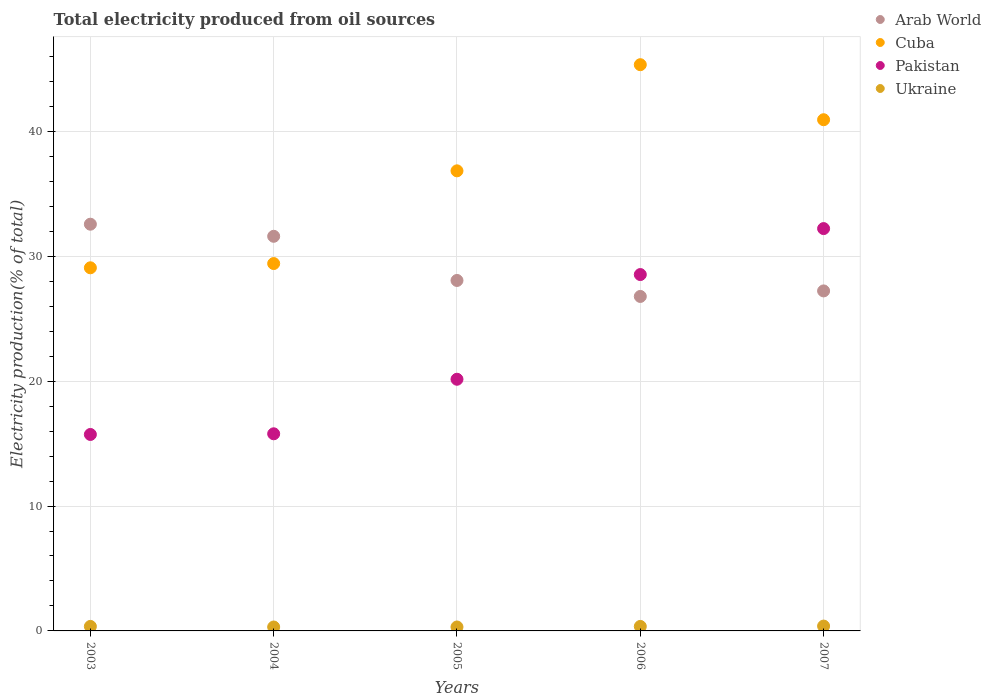What is the total electricity produced in Pakistan in 2006?
Keep it short and to the point. 28.53. Across all years, what is the maximum total electricity produced in Ukraine?
Give a very brief answer. 0.39. Across all years, what is the minimum total electricity produced in Ukraine?
Make the answer very short. 0.31. In which year was the total electricity produced in Ukraine minimum?
Offer a very short reply. 2004. What is the total total electricity produced in Cuba in the graph?
Your answer should be very brief. 181.61. What is the difference between the total electricity produced in Pakistan in 2003 and that in 2007?
Give a very brief answer. -16.49. What is the difference between the total electricity produced in Pakistan in 2004 and the total electricity produced in Cuba in 2003?
Offer a terse response. -13.29. What is the average total electricity produced in Arab World per year?
Offer a very short reply. 29.25. In the year 2007, what is the difference between the total electricity produced in Pakistan and total electricity produced in Arab World?
Offer a terse response. 4.99. What is the ratio of the total electricity produced in Cuba in 2003 to that in 2004?
Your answer should be compact. 0.99. Is the difference between the total electricity produced in Pakistan in 2004 and 2006 greater than the difference between the total electricity produced in Arab World in 2004 and 2006?
Ensure brevity in your answer.  No. What is the difference between the highest and the second highest total electricity produced in Arab World?
Ensure brevity in your answer.  0.97. What is the difference between the highest and the lowest total electricity produced in Cuba?
Make the answer very short. 16.26. Is the sum of the total electricity produced in Cuba in 2005 and 2006 greater than the maximum total electricity produced in Pakistan across all years?
Keep it short and to the point. Yes. Is it the case that in every year, the sum of the total electricity produced in Ukraine and total electricity produced in Pakistan  is greater than the sum of total electricity produced in Cuba and total electricity produced in Arab World?
Provide a short and direct response. No. Is it the case that in every year, the sum of the total electricity produced in Cuba and total electricity produced in Arab World  is greater than the total electricity produced in Pakistan?
Offer a terse response. Yes. Is the total electricity produced in Pakistan strictly greater than the total electricity produced in Ukraine over the years?
Your answer should be compact. Yes. Are the values on the major ticks of Y-axis written in scientific E-notation?
Your response must be concise. No. Does the graph contain any zero values?
Give a very brief answer. No. Does the graph contain grids?
Make the answer very short. Yes. How are the legend labels stacked?
Ensure brevity in your answer.  Vertical. What is the title of the graph?
Offer a very short reply. Total electricity produced from oil sources. What is the label or title of the Y-axis?
Offer a terse response. Electricity production(% of total). What is the Electricity production(% of total) of Arab World in 2003?
Your response must be concise. 32.57. What is the Electricity production(% of total) of Cuba in 2003?
Keep it short and to the point. 29.08. What is the Electricity production(% of total) in Pakistan in 2003?
Make the answer very short. 15.73. What is the Electricity production(% of total) of Ukraine in 2003?
Keep it short and to the point. 0.36. What is the Electricity production(% of total) in Arab World in 2004?
Give a very brief answer. 31.6. What is the Electricity production(% of total) in Cuba in 2004?
Offer a very short reply. 29.42. What is the Electricity production(% of total) of Pakistan in 2004?
Provide a succinct answer. 15.78. What is the Electricity production(% of total) in Ukraine in 2004?
Your answer should be very brief. 0.31. What is the Electricity production(% of total) in Arab World in 2005?
Your response must be concise. 28.06. What is the Electricity production(% of total) of Cuba in 2005?
Your answer should be very brief. 36.84. What is the Electricity production(% of total) of Pakistan in 2005?
Provide a short and direct response. 20.15. What is the Electricity production(% of total) in Ukraine in 2005?
Your answer should be compact. 0.32. What is the Electricity production(% of total) in Arab World in 2006?
Ensure brevity in your answer.  26.78. What is the Electricity production(% of total) in Cuba in 2006?
Your answer should be compact. 45.34. What is the Electricity production(% of total) in Pakistan in 2006?
Make the answer very short. 28.53. What is the Electricity production(% of total) in Ukraine in 2006?
Your response must be concise. 0.36. What is the Electricity production(% of total) of Arab World in 2007?
Make the answer very short. 27.23. What is the Electricity production(% of total) of Cuba in 2007?
Offer a very short reply. 40.93. What is the Electricity production(% of total) in Pakistan in 2007?
Ensure brevity in your answer.  32.22. What is the Electricity production(% of total) of Ukraine in 2007?
Ensure brevity in your answer.  0.39. Across all years, what is the maximum Electricity production(% of total) in Arab World?
Ensure brevity in your answer.  32.57. Across all years, what is the maximum Electricity production(% of total) in Cuba?
Your response must be concise. 45.34. Across all years, what is the maximum Electricity production(% of total) of Pakistan?
Ensure brevity in your answer.  32.22. Across all years, what is the maximum Electricity production(% of total) in Ukraine?
Your response must be concise. 0.39. Across all years, what is the minimum Electricity production(% of total) of Arab World?
Your response must be concise. 26.78. Across all years, what is the minimum Electricity production(% of total) of Cuba?
Your answer should be compact. 29.08. Across all years, what is the minimum Electricity production(% of total) in Pakistan?
Offer a terse response. 15.73. Across all years, what is the minimum Electricity production(% of total) in Ukraine?
Provide a succinct answer. 0.31. What is the total Electricity production(% of total) of Arab World in the graph?
Your answer should be very brief. 146.24. What is the total Electricity production(% of total) of Cuba in the graph?
Provide a short and direct response. 181.61. What is the total Electricity production(% of total) in Pakistan in the graph?
Provide a succinct answer. 112.42. What is the total Electricity production(% of total) in Ukraine in the graph?
Your answer should be compact. 1.74. What is the difference between the Electricity production(% of total) of Arab World in 2003 and that in 2004?
Your answer should be very brief. 0.97. What is the difference between the Electricity production(% of total) of Cuba in 2003 and that in 2004?
Offer a very short reply. -0.34. What is the difference between the Electricity production(% of total) of Pakistan in 2003 and that in 2004?
Keep it short and to the point. -0.05. What is the difference between the Electricity production(% of total) of Ukraine in 2003 and that in 2004?
Keep it short and to the point. 0.05. What is the difference between the Electricity production(% of total) of Arab World in 2003 and that in 2005?
Offer a terse response. 4.5. What is the difference between the Electricity production(% of total) of Cuba in 2003 and that in 2005?
Give a very brief answer. -7.76. What is the difference between the Electricity production(% of total) of Pakistan in 2003 and that in 2005?
Offer a terse response. -4.42. What is the difference between the Electricity production(% of total) of Ukraine in 2003 and that in 2005?
Your response must be concise. 0.05. What is the difference between the Electricity production(% of total) of Arab World in 2003 and that in 2006?
Your answer should be compact. 5.78. What is the difference between the Electricity production(% of total) in Cuba in 2003 and that in 2006?
Provide a short and direct response. -16.26. What is the difference between the Electricity production(% of total) of Pakistan in 2003 and that in 2006?
Offer a terse response. -12.8. What is the difference between the Electricity production(% of total) in Ukraine in 2003 and that in 2006?
Your response must be concise. 0. What is the difference between the Electricity production(% of total) of Arab World in 2003 and that in 2007?
Provide a short and direct response. 5.34. What is the difference between the Electricity production(% of total) of Cuba in 2003 and that in 2007?
Offer a terse response. -11.86. What is the difference between the Electricity production(% of total) in Pakistan in 2003 and that in 2007?
Provide a succinct answer. -16.49. What is the difference between the Electricity production(% of total) in Ukraine in 2003 and that in 2007?
Offer a very short reply. -0.03. What is the difference between the Electricity production(% of total) in Arab World in 2004 and that in 2005?
Provide a short and direct response. 3.54. What is the difference between the Electricity production(% of total) in Cuba in 2004 and that in 2005?
Provide a short and direct response. -7.42. What is the difference between the Electricity production(% of total) in Pakistan in 2004 and that in 2005?
Your answer should be very brief. -4.37. What is the difference between the Electricity production(% of total) in Ukraine in 2004 and that in 2005?
Provide a short and direct response. -0. What is the difference between the Electricity production(% of total) of Arab World in 2004 and that in 2006?
Your answer should be compact. 4.82. What is the difference between the Electricity production(% of total) of Cuba in 2004 and that in 2006?
Offer a very short reply. -15.92. What is the difference between the Electricity production(% of total) in Pakistan in 2004 and that in 2006?
Make the answer very short. -12.75. What is the difference between the Electricity production(% of total) in Ukraine in 2004 and that in 2006?
Your answer should be compact. -0.05. What is the difference between the Electricity production(% of total) of Arab World in 2004 and that in 2007?
Offer a terse response. 4.37. What is the difference between the Electricity production(% of total) of Cuba in 2004 and that in 2007?
Provide a short and direct response. -11.52. What is the difference between the Electricity production(% of total) in Pakistan in 2004 and that in 2007?
Make the answer very short. -16.43. What is the difference between the Electricity production(% of total) in Ukraine in 2004 and that in 2007?
Offer a terse response. -0.07. What is the difference between the Electricity production(% of total) in Arab World in 2005 and that in 2006?
Give a very brief answer. 1.28. What is the difference between the Electricity production(% of total) of Cuba in 2005 and that in 2006?
Make the answer very short. -8.5. What is the difference between the Electricity production(% of total) in Pakistan in 2005 and that in 2006?
Provide a succinct answer. -8.38. What is the difference between the Electricity production(% of total) in Ukraine in 2005 and that in 2006?
Offer a terse response. -0.04. What is the difference between the Electricity production(% of total) of Arab World in 2005 and that in 2007?
Keep it short and to the point. 0.84. What is the difference between the Electricity production(% of total) of Cuba in 2005 and that in 2007?
Your response must be concise. -4.09. What is the difference between the Electricity production(% of total) of Pakistan in 2005 and that in 2007?
Your response must be concise. -12.06. What is the difference between the Electricity production(% of total) in Ukraine in 2005 and that in 2007?
Provide a short and direct response. -0.07. What is the difference between the Electricity production(% of total) of Arab World in 2006 and that in 2007?
Make the answer very short. -0.44. What is the difference between the Electricity production(% of total) in Cuba in 2006 and that in 2007?
Keep it short and to the point. 4.41. What is the difference between the Electricity production(% of total) of Pakistan in 2006 and that in 2007?
Keep it short and to the point. -3.68. What is the difference between the Electricity production(% of total) in Ukraine in 2006 and that in 2007?
Ensure brevity in your answer.  -0.03. What is the difference between the Electricity production(% of total) of Arab World in 2003 and the Electricity production(% of total) of Cuba in 2004?
Ensure brevity in your answer.  3.15. What is the difference between the Electricity production(% of total) of Arab World in 2003 and the Electricity production(% of total) of Pakistan in 2004?
Your response must be concise. 16.78. What is the difference between the Electricity production(% of total) of Arab World in 2003 and the Electricity production(% of total) of Ukraine in 2004?
Provide a succinct answer. 32.25. What is the difference between the Electricity production(% of total) in Cuba in 2003 and the Electricity production(% of total) in Pakistan in 2004?
Ensure brevity in your answer.  13.29. What is the difference between the Electricity production(% of total) of Cuba in 2003 and the Electricity production(% of total) of Ukraine in 2004?
Give a very brief answer. 28.76. What is the difference between the Electricity production(% of total) in Pakistan in 2003 and the Electricity production(% of total) in Ukraine in 2004?
Offer a terse response. 15.42. What is the difference between the Electricity production(% of total) in Arab World in 2003 and the Electricity production(% of total) in Cuba in 2005?
Offer a terse response. -4.27. What is the difference between the Electricity production(% of total) in Arab World in 2003 and the Electricity production(% of total) in Pakistan in 2005?
Your response must be concise. 12.42. What is the difference between the Electricity production(% of total) of Arab World in 2003 and the Electricity production(% of total) of Ukraine in 2005?
Your answer should be very brief. 32.25. What is the difference between the Electricity production(% of total) of Cuba in 2003 and the Electricity production(% of total) of Pakistan in 2005?
Offer a very short reply. 8.92. What is the difference between the Electricity production(% of total) of Cuba in 2003 and the Electricity production(% of total) of Ukraine in 2005?
Make the answer very short. 28.76. What is the difference between the Electricity production(% of total) in Pakistan in 2003 and the Electricity production(% of total) in Ukraine in 2005?
Offer a terse response. 15.42. What is the difference between the Electricity production(% of total) in Arab World in 2003 and the Electricity production(% of total) in Cuba in 2006?
Offer a terse response. -12.77. What is the difference between the Electricity production(% of total) in Arab World in 2003 and the Electricity production(% of total) in Pakistan in 2006?
Keep it short and to the point. 4.03. What is the difference between the Electricity production(% of total) in Arab World in 2003 and the Electricity production(% of total) in Ukraine in 2006?
Provide a short and direct response. 32.21. What is the difference between the Electricity production(% of total) in Cuba in 2003 and the Electricity production(% of total) in Pakistan in 2006?
Offer a very short reply. 0.54. What is the difference between the Electricity production(% of total) of Cuba in 2003 and the Electricity production(% of total) of Ukraine in 2006?
Ensure brevity in your answer.  28.72. What is the difference between the Electricity production(% of total) of Pakistan in 2003 and the Electricity production(% of total) of Ukraine in 2006?
Your response must be concise. 15.37. What is the difference between the Electricity production(% of total) in Arab World in 2003 and the Electricity production(% of total) in Cuba in 2007?
Offer a very short reply. -8.37. What is the difference between the Electricity production(% of total) in Arab World in 2003 and the Electricity production(% of total) in Pakistan in 2007?
Your answer should be compact. 0.35. What is the difference between the Electricity production(% of total) in Arab World in 2003 and the Electricity production(% of total) in Ukraine in 2007?
Provide a succinct answer. 32.18. What is the difference between the Electricity production(% of total) in Cuba in 2003 and the Electricity production(% of total) in Pakistan in 2007?
Make the answer very short. -3.14. What is the difference between the Electricity production(% of total) of Cuba in 2003 and the Electricity production(% of total) of Ukraine in 2007?
Give a very brief answer. 28.69. What is the difference between the Electricity production(% of total) of Pakistan in 2003 and the Electricity production(% of total) of Ukraine in 2007?
Your answer should be compact. 15.34. What is the difference between the Electricity production(% of total) in Arab World in 2004 and the Electricity production(% of total) in Cuba in 2005?
Make the answer very short. -5.24. What is the difference between the Electricity production(% of total) of Arab World in 2004 and the Electricity production(% of total) of Pakistan in 2005?
Make the answer very short. 11.45. What is the difference between the Electricity production(% of total) in Arab World in 2004 and the Electricity production(% of total) in Ukraine in 2005?
Offer a terse response. 31.28. What is the difference between the Electricity production(% of total) in Cuba in 2004 and the Electricity production(% of total) in Pakistan in 2005?
Your answer should be very brief. 9.26. What is the difference between the Electricity production(% of total) in Cuba in 2004 and the Electricity production(% of total) in Ukraine in 2005?
Provide a succinct answer. 29.1. What is the difference between the Electricity production(% of total) of Pakistan in 2004 and the Electricity production(% of total) of Ukraine in 2005?
Provide a short and direct response. 15.47. What is the difference between the Electricity production(% of total) in Arab World in 2004 and the Electricity production(% of total) in Cuba in 2006?
Your answer should be compact. -13.74. What is the difference between the Electricity production(% of total) in Arab World in 2004 and the Electricity production(% of total) in Pakistan in 2006?
Ensure brevity in your answer.  3.06. What is the difference between the Electricity production(% of total) in Arab World in 2004 and the Electricity production(% of total) in Ukraine in 2006?
Offer a terse response. 31.24. What is the difference between the Electricity production(% of total) in Cuba in 2004 and the Electricity production(% of total) in Pakistan in 2006?
Ensure brevity in your answer.  0.88. What is the difference between the Electricity production(% of total) in Cuba in 2004 and the Electricity production(% of total) in Ukraine in 2006?
Offer a very short reply. 29.06. What is the difference between the Electricity production(% of total) of Pakistan in 2004 and the Electricity production(% of total) of Ukraine in 2006?
Your answer should be very brief. 15.42. What is the difference between the Electricity production(% of total) of Arab World in 2004 and the Electricity production(% of total) of Cuba in 2007?
Make the answer very short. -9.33. What is the difference between the Electricity production(% of total) in Arab World in 2004 and the Electricity production(% of total) in Pakistan in 2007?
Make the answer very short. -0.62. What is the difference between the Electricity production(% of total) in Arab World in 2004 and the Electricity production(% of total) in Ukraine in 2007?
Your answer should be very brief. 31.21. What is the difference between the Electricity production(% of total) in Cuba in 2004 and the Electricity production(% of total) in Pakistan in 2007?
Your response must be concise. -2.8. What is the difference between the Electricity production(% of total) of Cuba in 2004 and the Electricity production(% of total) of Ukraine in 2007?
Make the answer very short. 29.03. What is the difference between the Electricity production(% of total) in Pakistan in 2004 and the Electricity production(% of total) in Ukraine in 2007?
Offer a terse response. 15.4. What is the difference between the Electricity production(% of total) of Arab World in 2005 and the Electricity production(% of total) of Cuba in 2006?
Provide a short and direct response. -17.28. What is the difference between the Electricity production(% of total) in Arab World in 2005 and the Electricity production(% of total) in Pakistan in 2006?
Your answer should be very brief. -0.47. What is the difference between the Electricity production(% of total) in Arab World in 2005 and the Electricity production(% of total) in Ukraine in 2006?
Keep it short and to the point. 27.7. What is the difference between the Electricity production(% of total) of Cuba in 2005 and the Electricity production(% of total) of Pakistan in 2006?
Offer a terse response. 8.31. What is the difference between the Electricity production(% of total) in Cuba in 2005 and the Electricity production(% of total) in Ukraine in 2006?
Keep it short and to the point. 36.48. What is the difference between the Electricity production(% of total) of Pakistan in 2005 and the Electricity production(% of total) of Ukraine in 2006?
Make the answer very short. 19.79. What is the difference between the Electricity production(% of total) of Arab World in 2005 and the Electricity production(% of total) of Cuba in 2007?
Keep it short and to the point. -12.87. What is the difference between the Electricity production(% of total) in Arab World in 2005 and the Electricity production(% of total) in Pakistan in 2007?
Offer a very short reply. -4.15. What is the difference between the Electricity production(% of total) of Arab World in 2005 and the Electricity production(% of total) of Ukraine in 2007?
Your answer should be compact. 27.68. What is the difference between the Electricity production(% of total) of Cuba in 2005 and the Electricity production(% of total) of Pakistan in 2007?
Ensure brevity in your answer.  4.62. What is the difference between the Electricity production(% of total) of Cuba in 2005 and the Electricity production(% of total) of Ukraine in 2007?
Ensure brevity in your answer.  36.45. What is the difference between the Electricity production(% of total) of Pakistan in 2005 and the Electricity production(% of total) of Ukraine in 2007?
Provide a short and direct response. 19.76. What is the difference between the Electricity production(% of total) in Arab World in 2006 and the Electricity production(% of total) in Cuba in 2007?
Keep it short and to the point. -14.15. What is the difference between the Electricity production(% of total) in Arab World in 2006 and the Electricity production(% of total) in Pakistan in 2007?
Your answer should be compact. -5.43. What is the difference between the Electricity production(% of total) in Arab World in 2006 and the Electricity production(% of total) in Ukraine in 2007?
Keep it short and to the point. 26.4. What is the difference between the Electricity production(% of total) in Cuba in 2006 and the Electricity production(% of total) in Pakistan in 2007?
Keep it short and to the point. 13.12. What is the difference between the Electricity production(% of total) of Cuba in 2006 and the Electricity production(% of total) of Ukraine in 2007?
Offer a very short reply. 44.95. What is the difference between the Electricity production(% of total) in Pakistan in 2006 and the Electricity production(% of total) in Ukraine in 2007?
Provide a succinct answer. 28.15. What is the average Electricity production(% of total) in Arab World per year?
Offer a terse response. 29.25. What is the average Electricity production(% of total) of Cuba per year?
Make the answer very short. 36.32. What is the average Electricity production(% of total) in Pakistan per year?
Ensure brevity in your answer.  22.48. What is the average Electricity production(% of total) of Ukraine per year?
Ensure brevity in your answer.  0.35. In the year 2003, what is the difference between the Electricity production(% of total) in Arab World and Electricity production(% of total) in Cuba?
Make the answer very short. 3.49. In the year 2003, what is the difference between the Electricity production(% of total) in Arab World and Electricity production(% of total) in Pakistan?
Ensure brevity in your answer.  16.84. In the year 2003, what is the difference between the Electricity production(% of total) of Arab World and Electricity production(% of total) of Ukraine?
Your response must be concise. 32.21. In the year 2003, what is the difference between the Electricity production(% of total) of Cuba and Electricity production(% of total) of Pakistan?
Your answer should be compact. 13.35. In the year 2003, what is the difference between the Electricity production(% of total) of Cuba and Electricity production(% of total) of Ukraine?
Offer a very short reply. 28.72. In the year 2003, what is the difference between the Electricity production(% of total) in Pakistan and Electricity production(% of total) in Ukraine?
Provide a succinct answer. 15.37. In the year 2004, what is the difference between the Electricity production(% of total) in Arab World and Electricity production(% of total) in Cuba?
Keep it short and to the point. 2.18. In the year 2004, what is the difference between the Electricity production(% of total) of Arab World and Electricity production(% of total) of Pakistan?
Make the answer very short. 15.81. In the year 2004, what is the difference between the Electricity production(% of total) in Arab World and Electricity production(% of total) in Ukraine?
Your answer should be very brief. 31.29. In the year 2004, what is the difference between the Electricity production(% of total) of Cuba and Electricity production(% of total) of Pakistan?
Ensure brevity in your answer.  13.63. In the year 2004, what is the difference between the Electricity production(% of total) of Cuba and Electricity production(% of total) of Ukraine?
Make the answer very short. 29.1. In the year 2004, what is the difference between the Electricity production(% of total) of Pakistan and Electricity production(% of total) of Ukraine?
Your response must be concise. 15.47. In the year 2005, what is the difference between the Electricity production(% of total) of Arab World and Electricity production(% of total) of Cuba?
Your response must be concise. -8.78. In the year 2005, what is the difference between the Electricity production(% of total) of Arab World and Electricity production(% of total) of Pakistan?
Give a very brief answer. 7.91. In the year 2005, what is the difference between the Electricity production(% of total) of Arab World and Electricity production(% of total) of Ukraine?
Your response must be concise. 27.75. In the year 2005, what is the difference between the Electricity production(% of total) of Cuba and Electricity production(% of total) of Pakistan?
Your response must be concise. 16.69. In the year 2005, what is the difference between the Electricity production(% of total) in Cuba and Electricity production(% of total) in Ukraine?
Your answer should be very brief. 36.52. In the year 2005, what is the difference between the Electricity production(% of total) in Pakistan and Electricity production(% of total) in Ukraine?
Make the answer very short. 19.84. In the year 2006, what is the difference between the Electricity production(% of total) in Arab World and Electricity production(% of total) in Cuba?
Your answer should be very brief. -18.56. In the year 2006, what is the difference between the Electricity production(% of total) in Arab World and Electricity production(% of total) in Pakistan?
Make the answer very short. -1.75. In the year 2006, what is the difference between the Electricity production(% of total) of Arab World and Electricity production(% of total) of Ukraine?
Ensure brevity in your answer.  26.42. In the year 2006, what is the difference between the Electricity production(% of total) in Cuba and Electricity production(% of total) in Pakistan?
Your answer should be compact. 16.8. In the year 2006, what is the difference between the Electricity production(% of total) of Cuba and Electricity production(% of total) of Ukraine?
Offer a terse response. 44.98. In the year 2006, what is the difference between the Electricity production(% of total) in Pakistan and Electricity production(% of total) in Ukraine?
Ensure brevity in your answer.  28.18. In the year 2007, what is the difference between the Electricity production(% of total) of Arab World and Electricity production(% of total) of Cuba?
Keep it short and to the point. -13.71. In the year 2007, what is the difference between the Electricity production(% of total) in Arab World and Electricity production(% of total) in Pakistan?
Provide a short and direct response. -4.99. In the year 2007, what is the difference between the Electricity production(% of total) of Arab World and Electricity production(% of total) of Ukraine?
Keep it short and to the point. 26.84. In the year 2007, what is the difference between the Electricity production(% of total) in Cuba and Electricity production(% of total) in Pakistan?
Offer a terse response. 8.72. In the year 2007, what is the difference between the Electricity production(% of total) of Cuba and Electricity production(% of total) of Ukraine?
Provide a succinct answer. 40.55. In the year 2007, what is the difference between the Electricity production(% of total) of Pakistan and Electricity production(% of total) of Ukraine?
Ensure brevity in your answer.  31.83. What is the ratio of the Electricity production(% of total) in Arab World in 2003 to that in 2004?
Your answer should be very brief. 1.03. What is the ratio of the Electricity production(% of total) of Cuba in 2003 to that in 2004?
Your response must be concise. 0.99. What is the ratio of the Electricity production(% of total) in Ukraine in 2003 to that in 2004?
Ensure brevity in your answer.  1.15. What is the ratio of the Electricity production(% of total) in Arab World in 2003 to that in 2005?
Provide a succinct answer. 1.16. What is the ratio of the Electricity production(% of total) of Cuba in 2003 to that in 2005?
Ensure brevity in your answer.  0.79. What is the ratio of the Electricity production(% of total) of Pakistan in 2003 to that in 2005?
Provide a short and direct response. 0.78. What is the ratio of the Electricity production(% of total) of Ukraine in 2003 to that in 2005?
Make the answer very short. 1.14. What is the ratio of the Electricity production(% of total) of Arab World in 2003 to that in 2006?
Your answer should be very brief. 1.22. What is the ratio of the Electricity production(% of total) in Cuba in 2003 to that in 2006?
Provide a succinct answer. 0.64. What is the ratio of the Electricity production(% of total) of Pakistan in 2003 to that in 2006?
Provide a succinct answer. 0.55. What is the ratio of the Electricity production(% of total) of Ukraine in 2003 to that in 2006?
Make the answer very short. 1. What is the ratio of the Electricity production(% of total) of Arab World in 2003 to that in 2007?
Keep it short and to the point. 1.2. What is the ratio of the Electricity production(% of total) in Cuba in 2003 to that in 2007?
Give a very brief answer. 0.71. What is the ratio of the Electricity production(% of total) in Pakistan in 2003 to that in 2007?
Keep it short and to the point. 0.49. What is the ratio of the Electricity production(% of total) of Ukraine in 2003 to that in 2007?
Keep it short and to the point. 0.93. What is the ratio of the Electricity production(% of total) of Arab World in 2004 to that in 2005?
Offer a terse response. 1.13. What is the ratio of the Electricity production(% of total) in Cuba in 2004 to that in 2005?
Your response must be concise. 0.8. What is the ratio of the Electricity production(% of total) of Pakistan in 2004 to that in 2005?
Make the answer very short. 0.78. What is the ratio of the Electricity production(% of total) of Ukraine in 2004 to that in 2005?
Your answer should be very brief. 0.99. What is the ratio of the Electricity production(% of total) in Arab World in 2004 to that in 2006?
Offer a very short reply. 1.18. What is the ratio of the Electricity production(% of total) in Cuba in 2004 to that in 2006?
Offer a very short reply. 0.65. What is the ratio of the Electricity production(% of total) of Pakistan in 2004 to that in 2006?
Keep it short and to the point. 0.55. What is the ratio of the Electricity production(% of total) of Ukraine in 2004 to that in 2006?
Offer a terse response. 0.87. What is the ratio of the Electricity production(% of total) of Arab World in 2004 to that in 2007?
Your answer should be compact. 1.16. What is the ratio of the Electricity production(% of total) in Cuba in 2004 to that in 2007?
Provide a succinct answer. 0.72. What is the ratio of the Electricity production(% of total) in Pakistan in 2004 to that in 2007?
Offer a very short reply. 0.49. What is the ratio of the Electricity production(% of total) in Ukraine in 2004 to that in 2007?
Offer a terse response. 0.81. What is the ratio of the Electricity production(% of total) of Arab World in 2005 to that in 2006?
Give a very brief answer. 1.05. What is the ratio of the Electricity production(% of total) in Cuba in 2005 to that in 2006?
Offer a very short reply. 0.81. What is the ratio of the Electricity production(% of total) of Pakistan in 2005 to that in 2006?
Make the answer very short. 0.71. What is the ratio of the Electricity production(% of total) of Ukraine in 2005 to that in 2006?
Your response must be concise. 0.88. What is the ratio of the Electricity production(% of total) of Arab World in 2005 to that in 2007?
Provide a succinct answer. 1.03. What is the ratio of the Electricity production(% of total) of Pakistan in 2005 to that in 2007?
Your answer should be very brief. 0.63. What is the ratio of the Electricity production(% of total) in Ukraine in 2005 to that in 2007?
Provide a short and direct response. 0.81. What is the ratio of the Electricity production(% of total) of Arab World in 2006 to that in 2007?
Your answer should be very brief. 0.98. What is the ratio of the Electricity production(% of total) of Cuba in 2006 to that in 2007?
Offer a terse response. 1.11. What is the ratio of the Electricity production(% of total) of Pakistan in 2006 to that in 2007?
Ensure brevity in your answer.  0.89. What is the ratio of the Electricity production(% of total) of Ukraine in 2006 to that in 2007?
Make the answer very short. 0.93. What is the difference between the highest and the second highest Electricity production(% of total) in Arab World?
Offer a very short reply. 0.97. What is the difference between the highest and the second highest Electricity production(% of total) of Cuba?
Ensure brevity in your answer.  4.41. What is the difference between the highest and the second highest Electricity production(% of total) in Pakistan?
Your answer should be compact. 3.68. What is the difference between the highest and the second highest Electricity production(% of total) in Ukraine?
Offer a very short reply. 0.03. What is the difference between the highest and the lowest Electricity production(% of total) of Arab World?
Your answer should be very brief. 5.78. What is the difference between the highest and the lowest Electricity production(% of total) of Cuba?
Offer a very short reply. 16.26. What is the difference between the highest and the lowest Electricity production(% of total) in Pakistan?
Your answer should be very brief. 16.49. What is the difference between the highest and the lowest Electricity production(% of total) of Ukraine?
Offer a very short reply. 0.07. 